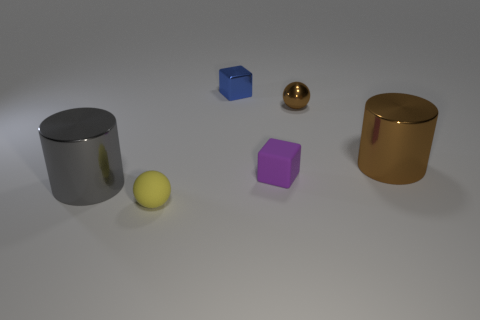There is a tiny thing that is left of the tiny purple matte thing and behind the purple rubber block; what is it made of?
Offer a terse response. Metal. Is the big object left of the small purple matte block made of the same material as the blue cube?
Offer a terse response. Yes. What is the material of the tiny brown object?
Your answer should be compact. Metal. There is a sphere that is to the left of the shiny block; what size is it?
Offer a very short reply. Small. Are there any other things that have the same color as the metal ball?
Ensure brevity in your answer.  Yes. Is there a small brown shiny object that is to the right of the matte object that is to the left of the blue metallic block that is left of the metal ball?
Your answer should be very brief. Yes. There is a large metal cylinder that is right of the tiny purple matte thing; does it have the same color as the metallic sphere?
Your answer should be very brief. Yes. How many blocks are red objects or tiny brown metal objects?
Make the answer very short. 0. What shape is the big metal thing that is right of the blue metal block that is behind the brown ball?
Give a very brief answer. Cylinder. There is a cylinder that is in front of the large metal object that is on the right side of the gray metallic thing that is behind the small rubber ball; what size is it?
Offer a very short reply. Large. 